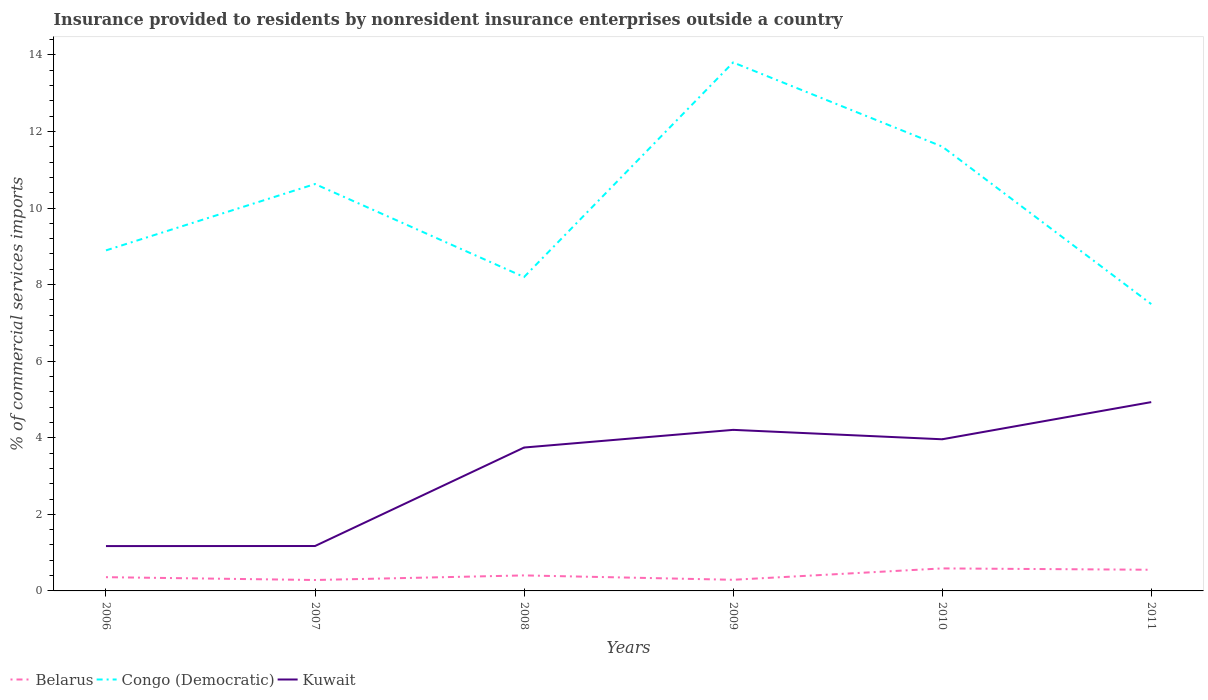How many different coloured lines are there?
Your answer should be compact. 3. Does the line corresponding to Congo (Democratic) intersect with the line corresponding to Belarus?
Give a very brief answer. No. Across all years, what is the maximum Insurance provided to residents in Congo (Democratic)?
Your response must be concise. 7.49. In which year was the Insurance provided to residents in Belarus maximum?
Provide a succinct answer. 2007. What is the total Insurance provided to residents in Belarus in the graph?
Your response must be concise. 0.04. What is the difference between the highest and the second highest Insurance provided to residents in Belarus?
Offer a very short reply. 0.3. How many lines are there?
Offer a very short reply. 3. What is the difference between two consecutive major ticks on the Y-axis?
Your answer should be compact. 2. Are the values on the major ticks of Y-axis written in scientific E-notation?
Provide a succinct answer. No. How are the legend labels stacked?
Ensure brevity in your answer.  Horizontal. What is the title of the graph?
Offer a very short reply. Insurance provided to residents by nonresident insurance enterprises outside a country. Does "Guinea-Bissau" appear as one of the legend labels in the graph?
Make the answer very short. No. What is the label or title of the X-axis?
Ensure brevity in your answer.  Years. What is the label or title of the Y-axis?
Provide a succinct answer. % of commercial services imports. What is the % of commercial services imports of Belarus in 2006?
Offer a very short reply. 0.36. What is the % of commercial services imports of Congo (Democratic) in 2006?
Give a very brief answer. 8.89. What is the % of commercial services imports of Kuwait in 2006?
Offer a very short reply. 1.17. What is the % of commercial services imports in Belarus in 2007?
Offer a terse response. 0.29. What is the % of commercial services imports of Congo (Democratic) in 2007?
Offer a very short reply. 10.63. What is the % of commercial services imports of Kuwait in 2007?
Make the answer very short. 1.17. What is the % of commercial services imports in Belarus in 2008?
Your answer should be compact. 0.41. What is the % of commercial services imports in Congo (Democratic) in 2008?
Provide a short and direct response. 8.2. What is the % of commercial services imports in Kuwait in 2008?
Your answer should be compact. 3.75. What is the % of commercial services imports in Belarus in 2009?
Ensure brevity in your answer.  0.29. What is the % of commercial services imports in Congo (Democratic) in 2009?
Give a very brief answer. 13.8. What is the % of commercial services imports of Kuwait in 2009?
Your answer should be compact. 4.21. What is the % of commercial services imports in Belarus in 2010?
Give a very brief answer. 0.59. What is the % of commercial services imports in Congo (Democratic) in 2010?
Offer a very short reply. 11.61. What is the % of commercial services imports in Kuwait in 2010?
Offer a terse response. 3.96. What is the % of commercial services imports of Belarus in 2011?
Ensure brevity in your answer.  0.55. What is the % of commercial services imports in Congo (Democratic) in 2011?
Give a very brief answer. 7.49. What is the % of commercial services imports of Kuwait in 2011?
Your answer should be very brief. 4.93. Across all years, what is the maximum % of commercial services imports in Belarus?
Provide a succinct answer. 0.59. Across all years, what is the maximum % of commercial services imports of Congo (Democratic)?
Ensure brevity in your answer.  13.8. Across all years, what is the maximum % of commercial services imports in Kuwait?
Give a very brief answer. 4.93. Across all years, what is the minimum % of commercial services imports of Belarus?
Give a very brief answer. 0.29. Across all years, what is the minimum % of commercial services imports of Congo (Democratic)?
Offer a very short reply. 7.49. Across all years, what is the minimum % of commercial services imports in Kuwait?
Provide a succinct answer. 1.17. What is the total % of commercial services imports of Belarus in the graph?
Offer a terse response. 2.48. What is the total % of commercial services imports in Congo (Democratic) in the graph?
Give a very brief answer. 60.62. What is the total % of commercial services imports of Kuwait in the graph?
Provide a succinct answer. 19.19. What is the difference between the % of commercial services imports in Belarus in 2006 and that in 2007?
Your answer should be compact. 0.07. What is the difference between the % of commercial services imports in Congo (Democratic) in 2006 and that in 2007?
Offer a terse response. -1.73. What is the difference between the % of commercial services imports in Kuwait in 2006 and that in 2007?
Provide a succinct answer. -0. What is the difference between the % of commercial services imports in Belarus in 2006 and that in 2008?
Make the answer very short. -0.05. What is the difference between the % of commercial services imports in Congo (Democratic) in 2006 and that in 2008?
Your answer should be compact. 0.69. What is the difference between the % of commercial services imports in Kuwait in 2006 and that in 2008?
Keep it short and to the point. -2.57. What is the difference between the % of commercial services imports in Belarus in 2006 and that in 2009?
Give a very brief answer. 0.07. What is the difference between the % of commercial services imports of Congo (Democratic) in 2006 and that in 2009?
Give a very brief answer. -4.91. What is the difference between the % of commercial services imports in Kuwait in 2006 and that in 2009?
Keep it short and to the point. -3.04. What is the difference between the % of commercial services imports of Belarus in 2006 and that in 2010?
Your answer should be very brief. -0.23. What is the difference between the % of commercial services imports in Congo (Democratic) in 2006 and that in 2010?
Make the answer very short. -2.71. What is the difference between the % of commercial services imports in Kuwait in 2006 and that in 2010?
Provide a short and direct response. -2.79. What is the difference between the % of commercial services imports of Belarus in 2006 and that in 2011?
Ensure brevity in your answer.  -0.19. What is the difference between the % of commercial services imports in Congo (Democratic) in 2006 and that in 2011?
Your answer should be very brief. 1.4. What is the difference between the % of commercial services imports of Kuwait in 2006 and that in 2011?
Your response must be concise. -3.76. What is the difference between the % of commercial services imports in Belarus in 2007 and that in 2008?
Ensure brevity in your answer.  -0.12. What is the difference between the % of commercial services imports of Congo (Democratic) in 2007 and that in 2008?
Provide a short and direct response. 2.43. What is the difference between the % of commercial services imports of Kuwait in 2007 and that in 2008?
Keep it short and to the point. -2.57. What is the difference between the % of commercial services imports of Belarus in 2007 and that in 2009?
Your answer should be very brief. -0.01. What is the difference between the % of commercial services imports in Congo (Democratic) in 2007 and that in 2009?
Keep it short and to the point. -3.18. What is the difference between the % of commercial services imports in Kuwait in 2007 and that in 2009?
Make the answer very short. -3.03. What is the difference between the % of commercial services imports in Belarus in 2007 and that in 2010?
Your answer should be very brief. -0.3. What is the difference between the % of commercial services imports in Congo (Democratic) in 2007 and that in 2010?
Provide a short and direct response. -0.98. What is the difference between the % of commercial services imports of Kuwait in 2007 and that in 2010?
Your answer should be very brief. -2.79. What is the difference between the % of commercial services imports in Belarus in 2007 and that in 2011?
Provide a short and direct response. -0.27. What is the difference between the % of commercial services imports of Congo (Democratic) in 2007 and that in 2011?
Your response must be concise. 3.14. What is the difference between the % of commercial services imports of Kuwait in 2007 and that in 2011?
Provide a short and direct response. -3.76. What is the difference between the % of commercial services imports in Belarus in 2008 and that in 2009?
Offer a very short reply. 0.11. What is the difference between the % of commercial services imports in Congo (Democratic) in 2008 and that in 2009?
Your response must be concise. -5.6. What is the difference between the % of commercial services imports in Kuwait in 2008 and that in 2009?
Give a very brief answer. -0.46. What is the difference between the % of commercial services imports in Belarus in 2008 and that in 2010?
Give a very brief answer. -0.18. What is the difference between the % of commercial services imports of Congo (Democratic) in 2008 and that in 2010?
Your response must be concise. -3.41. What is the difference between the % of commercial services imports of Kuwait in 2008 and that in 2010?
Offer a terse response. -0.22. What is the difference between the % of commercial services imports of Belarus in 2008 and that in 2011?
Offer a very short reply. -0.15. What is the difference between the % of commercial services imports of Congo (Democratic) in 2008 and that in 2011?
Your answer should be very brief. 0.71. What is the difference between the % of commercial services imports of Kuwait in 2008 and that in 2011?
Your answer should be compact. -1.19. What is the difference between the % of commercial services imports in Belarus in 2009 and that in 2010?
Make the answer very short. -0.3. What is the difference between the % of commercial services imports in Congo (Democratic) in 2009 and that in 2010?
Give a very brief answer. 2.2. What is the difference between the % of commercial services imports in Kuwait in 2009 and that in 2010?
Provide a short and direct response. 0.25. What is the difference between the % of commercial services imports in Belarus in 2009 and that in 2011?
Make the answer very short. -0.26. What is the difference between the % of commercial services imports in Congo (Democratic) in 2009 and that in 2011?
Provide a succinct answer. 6.31. What is the difference between the % of commercial services imports of Kuwait in 2009 and that in 2011?
Your answer should be compact. -0.72. What is the difference between the % of commercial services imports of Belarus in 2010 and that in 2011?
Offer a very short reply. 0.04. What is the difference between the % of commercial services imports in Congo (Democratic) in 2010 and that in 2011?
Offer a terse response. 4.11. What is the difference between the % of commercial services imports in Kuwait in 2010 and that in 2011?
Provide a short and direct response. -0.97. What is the difference between the % of commercial services imports of Belarus in 2006 and the % of commercial services imports of Congo (Democratic) in 2007?
Keep it short and to the point. -10.27. What is the difference between the % of commercial services imports in Belarus in 2006 and the % of commercial services imports in Kuwait in 2007?
Offer a terse response. -0.81. What is the difference between the % of commercial services imports in Congo (Democratic) in 2006 and the % of commercial services imports in Kuwait in 2007?
Provide a succinct answer. 7.72. What is the difference between the % of commercial services imports of Belarus in 2006 and the % of commercial services imports of Congo (Democratic) in 2008?
Provide a succinct answer. -7.84. What is the difference between the % of commercial services imports of Belarus in 2006 and the % of commercial services imports of Kuwait in 2008?
Keep it short and to the point. -3.39. What is the difference between the % of commercial services imports of Congo (Democratic) in 2006 and the % of commercial services imports of Kuwait in 2008?
Provide a short and direct response. 5.15. What is the difference between the % of commercial services imports of Belarus in 2006 and the % of commercial services imports of Congo (Democratic) in 2009?
Make the answer very short. -13.44. What is the difference between the % of commercial services imports of Belarus in 2006 and the % of commercial services imports of Kuwait in 2009?
Give a very brief answer. -3.85. What is the difference between the % of commercial services imports of Congo (Democratic) in 2006 and the % of commercial services imports of Kuwait in 2009?
Your answer should be compact. 4.69. What is the difference between the % of commercial services imports of Belarus in 2006 and the % of commercial services imports of Congo (Democratic) in 2010?
Your response must be concise. -11.25. What is the difference between the % of commercial services imports of Belarus in 2006 and the % of commercial services imports of Kuwait in 2010?
Keep it short and to the point. -3.6. What is the difference between the % of commercial services imports of Congo (Democratic) in 2006 and the % of commercial services imports of Kuwait in 2010?
Keep it short and to the point. 4.93. What is the difference between the % of commercial services imports of Belarus in 2006 and the % of commercial services imports of Congo (Democratic) in 2011?
Provide a succinct answer. -7.13. What is the difference between the % of commercial services imports in Belarus in 2006 and the % of commercial services imports in Kuwait in 2011?
Give a very brief answer. -4.57. What is the difference between the % of commercial services imports of Congo (Democratic) in 2006 and the % of commercial services imports of Kuwait in 2011?
Your response must be concise. 3.96. What is the difference between the % of commercial services imports of Belarus in 2007 and the % of commercial services imports of Congo (Democratic) in 2008?
Your response must be concise. -7.91. What is the difference between the % of commercial services imports of Belarus in 2007 and the % of commercial services imports of Kuwait in 2008?
Your answer should be compact. -3.46. What is the difference between the % of commercial services imports in Congo (Democratic) in 2007 and the % of commercial services imports in Kuwait in 2008?
Keep it short and to the point. 6.88. What is the difference between the % of commercial services imports in Belarus in 2007 and the % of commercial services imports in Congo (Democratic) in 2009?
Give a very brief answer. -13.52. What is the difference between the % of commercial services imports of Belarus in 2007 and the % of commercial services imports of Kuwait in 2009?
Provide a short and direct response. -3.92. What is the difference between the % of commercial services imports in Congo (Democratic) in 2007 and the % of commercial services imports in Kuwait in 2009?
Offer a very short reply. 6.42. What is the difference between the % of commercial services imports of Belarus in 2007 and the % of commercial services imports of Congo (Democratic) in 2010?
Make the answer very short. -11.32. What is the difference between the % of commercial services imports in Belarus in 2007 and the % of commercial services imports in Kuwait in 2010?
Your answer should be compact. -3.68. What is the difference between the % of commercial services imports of Congo (Democratic) in 2007 and the % of commercial services imports of Kuwait in 2010?
Keep it short and to the point. 6.67. What is the difference between the % of commercial services imports of Belarus in 2007 and the % of commercial services imports of Congo (Democratic) in 2011?
Provide a short and direct response. -7.21. What is the difference between the % of commercial services imports of Belarus in 2007 and the % of commercial services imports of Kuwait in 2011?
Provide a short and direct response. -4.65. What is the difference between the % of commercial services imports of Congo (Democratic) in 2007 and the % of commercial services imports of Kuwait in 2011?
Offer a very short reply. 5.7. What is the difference between the % of commercial services imports of Belarus in 2008 and the % of commercial services imports of Congo (Democratic) in 2009?
Keep it short and to the point. -13.4. What is the difference between the % of commercial services imports of Belarus in 2008 and the % of commercial services imports of Kuwait in 2009?
Ensure brevity in your answer.  -3.8. What is the difference between the % of commercial services imports in Congo (Democratic) in 2008 and the % of commercial services imports in Kuwait in 2009?
Provide a succinct answer. 3.99. What is the difference between the % of commercial services imports in Belarus in 2008 and the % of commercial services imports in Congo (Democratic) in 2010?
Keep it short and to the point. -11.2. What is the difference between the % of commercial services imports of Belarus in 2008 and the % of commercial services imports of Kuwait in 2010?
Offer a very short reply. -3.56. What is the difference between the % of commercial services imports in Congo (Democratic) in 2008 and the % of commercial services imports in Kuwait in 2010?
Offer a very short reply. 4.24. What is the difference between the % of commercial services imports in Belarus in 2008 and the % of commercial services imports in Congo (Democratic) in 2011?
Keep it short and to the point. -7.09. What is the difference between the % of commercial services imports in Belarus in 2008 and the % of commercial services imports in Kuwait in 2011?
Your answer should be compact. -4.53. What is the difference between the % of commercial services imports in Congo (Democratic) in 2008 and the % of commercial services imports in Kuwait in 2011?
Give a very brief answer. 3.27. What is the difference between the % of commercial services imports of Belarus in 2009 and the % of commercial services imports of Congo (Democratic) in 2010?
Ensure brevity in your answer.  -11.31. What is the difference between the % of commercial services imports of Belarus in 2009 and the % of commercial services imports of Kuwait in 2010?
Offer a very short reply. -3.67. What is the difference between the % of commercial services imports in Congo (Democratic) in 2009 and the % of commercial services imports in Kuwait in 2010?
Keep it short and to the point. 9.84. What is the difference between the % of commercial services imports in Belarus in 2009 and the % of commercial services imports in Congo (Democratic) in 2011?
Offer a terse response. -7.2. What is the difference between the % of commercial services imports in Belarus in 2009 and the % of commercial services imports in Kuwait in 2011?
Your answer should be compact. -4.64. What is the difference between the % of commercial services imports in Congo (Democratic) in 2009 and the % of commercial services imports in Kuwait in 2011?
Give a very brief answer. 8.87. What is the difference between the % of commercial services imports of Belarus in 2010 and the % of commercial services imports of Congo (Democratic) in 2011?
Your answer should be very brief. -6.9. What is the difference between the % of commercial services imports in Belarus in 2010 and the % of commercial services imports in Kuwait in 2011?
Your answer should be very brief. -4.34. What is the difference between the % of commercial services imports in Congo (Democratic) in 2010 and the % of commercial services imports in Kuwait in 2011?
Your answer should be compact. 6.67. What is the average % of commercial services imports of Belarus per year?
Keep it short and to the point. 0.41. What is the average % of commercial services imports in Congo (Democratic) per year?
Your answer should be very brief. 10.1. What is the average % of commercial services imports of Kuwait per year?
Your answer should be very brief. 3.2. In the year 2006, what is the difference between the % of commercial services imports in Belarus and % of commercial services imports in Congo (Democratic)?
Your response must be concise. -8.53. In the year 2006, what is the difference between the % of commercial services imports of Belarus and % of commercial services imports of Kuwait?
Provide a short and direct response. -0.81. In the year 2006, what is the difference between the % of commercial services imports in Congo (Democratic) and % of commercial services imports in Kuwait?
Keep it short and to the point. 7.72. In the year 2007, what is the difference between the % of commercial services imports in Belarus and % of commercial services imports in Congo (Democratic)?
Your answer should be compact. -10.34. In the year 2007, what is the difference between the % of commercial services imports of Belarus and % of commercial services imports of Kuwait?
Provide a succinct answer. -0.89. In the year 2007, what is the difference between the % of commercial services imports in Congo (Democratic) and % of commercial services imports in Kuwait?
Make the answer very short. 9.45. In the year 2008, what is the difference between the % of commercial services imports in Belarus and % of commercial services imports in Congo (Democratic)?
Offer a very short reply. -7.79. In the year 2008, what is the difference between the % of commercial services imports in Belarus and % of commercial services imports in Kuwait?
Make the answer very short. -3.34. In the year 2008, what is the difference between the % of commercial services imports of Congo (Democratic) and % of commercial services imports of Kuwait?
Give a very brief answer. 4.45. In the year 2009, what is the difference between the % of commercial services imports in Belarus and % of commercial services imports in Congo (Democratic)?
Give a very brief answer. -13.51. In the year 2009, what is the difference between the % of commercial services imports of Belarus and % of commercial services imports of Kuwait?
Your response must be concise. -3.92. In the year 2009, what is the difference between the % of commercial services imports of Congo (Democratic) and % of commercial services imports of Kuwait?
Provide a succinct answer. 9.6. In the year 2010, what is the difference between the % of commercial services imports of Belarus and % of commercial services imports of Congo (Democratic)?
Offer a very short reply. -11.02. In the year 2010, what is the difference between the % of commercial services imports in Belarus and % of commercial services imports in Kuwait?
Give a very brief answer. -3.37. In the year 2010, what is the difference between the % of commercial services imports in Congo (Democratic) and % of commercial services imports in Kuwait?
Provide a short and direct response. 7.65. In the year 2011, what is the difference between the % of commercial services imports in Belarus and % of commercial services imports in Congo (Democratic)?
Give a very brief answer. -6.94. In the year 2011, what is the difference between the % of commercial services imports of Belarus and % of commercial services imports of Kuwait?
Make the answer very short. -4.38. In the year 2011, what is the difference between the % of commercial services imports of Congo (Democratic) and % of commercial services imports of Kuwait?
Make the answer very short. 2.56. What is the ratio of the % of commercial services imports of Belarus in 2006 to that in 2007?
Provide a short and direct response. 1.26. What is the ratio of the % of commercial services imports of Congo (Democratic) in 2006 to that in 2007?
Offer a terse response. 0.84. What is the ratio of the % of commercial services imports in Kuwait in 2006 to that in 2007?
Offer a terse response. 1. What is the ratio of the % of commercial services imports of Belarus in 2006 to that in 2008?
Keep it short and to the point. 0.89. What is the ratio of the % of commercial services imports of Congo (Democratic) in 2006 to that in 2008?
Give a very brief answer. 1.08. What is the ratio of the % of commercial services imports in Kuwait in 2006 to that in 2008?
Provide a short and direct response. 0.31. What is the ratio of the % of commercial services imports in Belarus in 2006 to that in 2009?
Your answer should be compact. 1.24. What is the ratio of the % of commercial services imports in Congo (Democratic) in 2006 to that in 2009?
Offer a very short reply. 0.64. What is the ratio of the % of commercial services imports of Kuwait in 2006 to that in 2009?
Give a very brief answer. 0.28. What is the ratio of the % of commercial services imports in Belarus in 2006 to that in 2010?
Your answer should be compact. 0.61. What is the ratio of the % of commercial services imports of Congo (Democratic) in 2006 to that in 2010?
Give a very brief answer. 0.77. What is the ratio of the % of commercial services imports of Kuwait in 2006 to that in 2010?
Offer a terse response. 0.3. What is the ratio of the % of commercial services imports in Belarus in 2006 to that in 2011?
Keep it short and to the point. 0.65. What is the ratio of the % of commercial services imports in Congo (Democratic) in 2006 to that in 2011?
Offer a very short reply. 1.19. What is the ratio of the % of commercial services imports of Kuwait in 2006 to that in 2011?
Your response must be concise. 0.24. What is the ratio of the % of commercial services imports of Belarus in 2007 to that in 2008?
Offer a terse response. 0.7. What is the ratio of the % of commercial services imports of Congo (Democratic) in 2007 to that in 2008?
Your response must be concise. 1.3. What is the ratio of the % of commercial services imports of Kuwait in 2007 to that in 2008?
Ensure brevity in your answer.  0.31. What is the ratio of the % of commercial services imports in Belarus in 2007 to that in 2009?
Give a very brief answer. 0.98. What is the ratio of the % of commercial services imports of Congo (Democratic) in 2007 to that in 2009?
Ensure brevity in your answer.  0.77. What is the ratio of the % of commercial services imports in Kuwait in 2007 to that in 2009?
Provide a succinct answer. 0.28. What is the ratio of the % of commercial services imports of Belarus in 2007 to that in 2010?
Provide a short and direct response. 0.48. What is the ratio of the % of commercial services imports in Congo (Democratic) in 2007 to that in 2010?
Your response must be concise. 0.92. What is the ratio of the % of commercial services imports of Kuwait in 2007 to that in 2010?
Offer a terse response. 0.3. What is the ratio of the % of commercial services imports of Belarus in 2007 to that in 2011?
Your response must be concise. 0.52. What is the ratio of the % of commercial services imports of Congo (Democratic) in 2007 to that in 2011?
Provide a succinct answer. 1.42. What is the ratio of the % of commercial services imports in Kuwait in 2007 to that in 2011?
Your response must be concise. 0.24. What is the ratio of the % of commercial services imports in Belarus in 2008 to that in 2009?
Keep it short and to the point. 1.39. What is the ratio of the % of commercial services imports in Congo (Democratic) in 2008 to that in 2009?
Offer a very short reply. 0.59. What is the ratio of the % of commercial services imports in Kuwait in 2008 to that in 2009?
Give a very brief answer. 0.89. What is the ratio of the % of commercial services imports of Belarus in 2008 to that in 2010?
Offer a terse response. 0.69. What is the ratio of the % of commercial services imports in Congo (Democratic) in 2008 to that in 2010?
Your answer should be compact. 0.71. What is the ratio of the % of commercial services imports in Kuwait in 2008 to that in 2010?
Keep it short and to the point. 0.95. What is the ratio of the % of commercial services imports of Belarus in 2008 to that in 2011?
Offer a very short reply. 0.73. What is the ratio of the % of commercial services imports of Congo (Democratic) in 2008 to that in 2011?
Your response must be concise. 1.09. What is the ratio of the % of commercial services imports in Kuwait in 2008 to that in 2011?
Keep it short and to the point. 0.76. What is the ratio of the % of commercial services imports of Belarus in 2009 to that in 2010?
Your answer should be compact. 0.49. What is the ratio of the % of commercial services imports of Congo (Democratic) in 2009 to that in 2010?
Offer a terse response. 1.19. What is the ratio of the % of commercial services imports of Kuwait in 2009 to that in 2010?
Your answer should be compact. 1.06. What is the ratio of the % of commercial services imports in Belarus in 2009 to that in 2011?
Keep it short and to the point. 0.53. What is the ratio of the % of commercial services imports in Congo (Democratic) in 2009 to that in 2011?
Give a very brief answer. 1.84. What is the ratio of the % of commercial services imports of Kuwait in 2009 to that in 2011?
Provide a short and direct response. 0.85. What is the ratio of the % of commercial services imports of Belarus in 2010 to that in 2011?
Your response must be concise. 1.06. What is the ratio of the % of commercial services imports in Congo (Democratic) in 2010 to that in 2011?
Your answer should be very brief. 1.55. What is the ratio of the % of commercial services imports of Kuwait in 2010 to that in 2011?
Offer a very short reply. 0.8. What is the difference between the highest and the second highest % of commercial services imports in Belarus?
Your answer should be compact. 0.04. What is the difference between the highest and the second highest % of commercial services imports of Congo (Democratic)?
Keep it short and to the point. 2.2. What is the difference between the highest and the second highest % of commercial services imports in Kuwait?
Your response must be concise. 0.72. What is the difference between the highest and the lowest % of commercial services imports of Belarus?
Offer a terse response. 0.3. What is the difference between the highest and the lowest % of commercial services imports in Congo (Democratic)?
Offer a very short reply. 6.31. What is the difference between the highest and the lowest % of commercial services imports in Kuwait?
Ensure brevity in your answer.  3.76. 